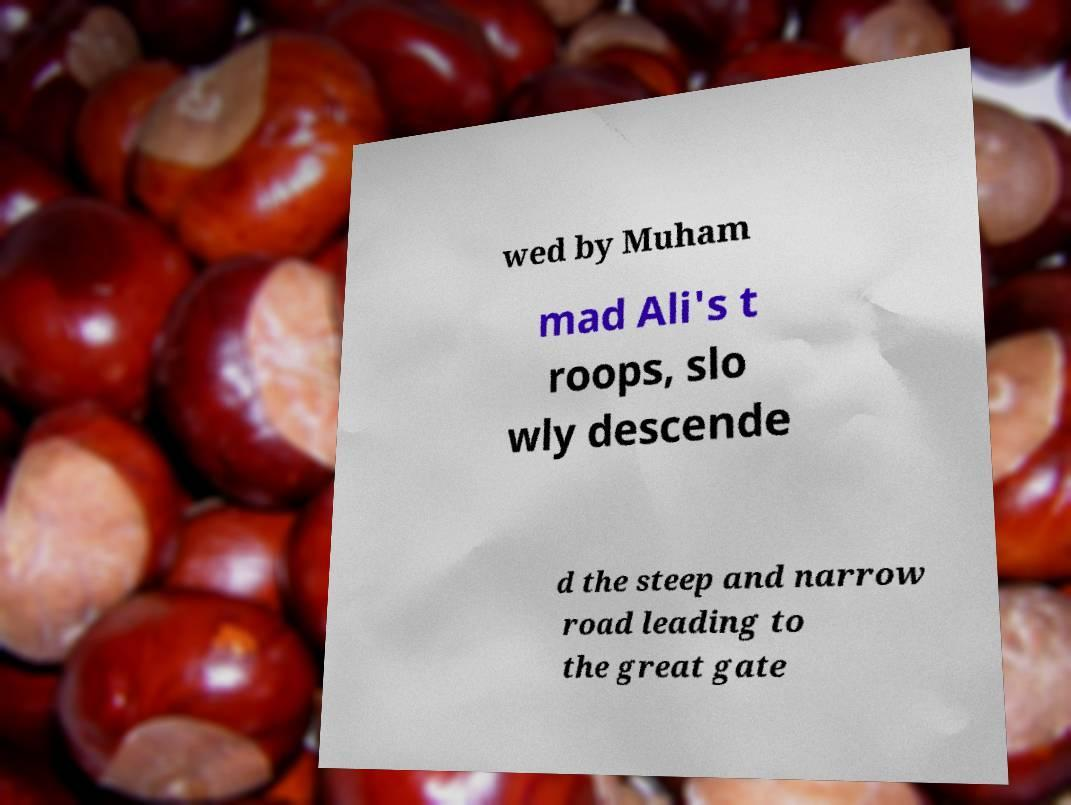Could you extract and type out the text from this image? wed by Muham mad Ali's t roops, slo wly descende d the steep and narrow road leading to the great gate 